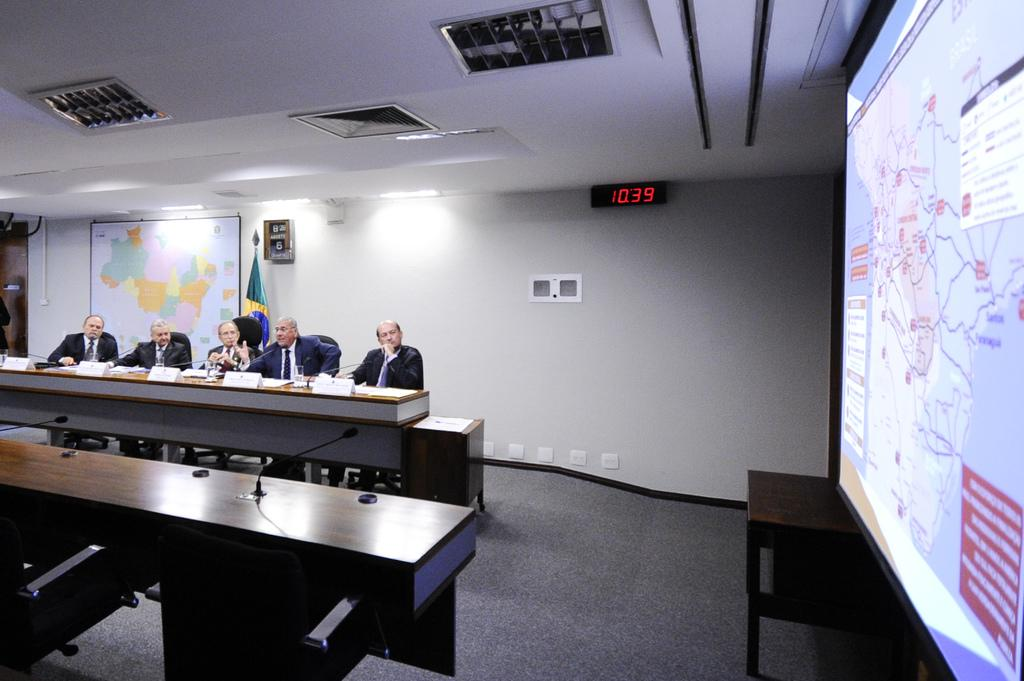How many people are sitting in the image? There are five persons sitting on chairs in the image. What can be seen in the background of the image? There is a world map and a light in the background. What is on the right side of the image? There is a projected image on the right side. What type of interest does the farmer have in the image? There is no farmer present in the image, so it is not possible to determine any interests they might have. 